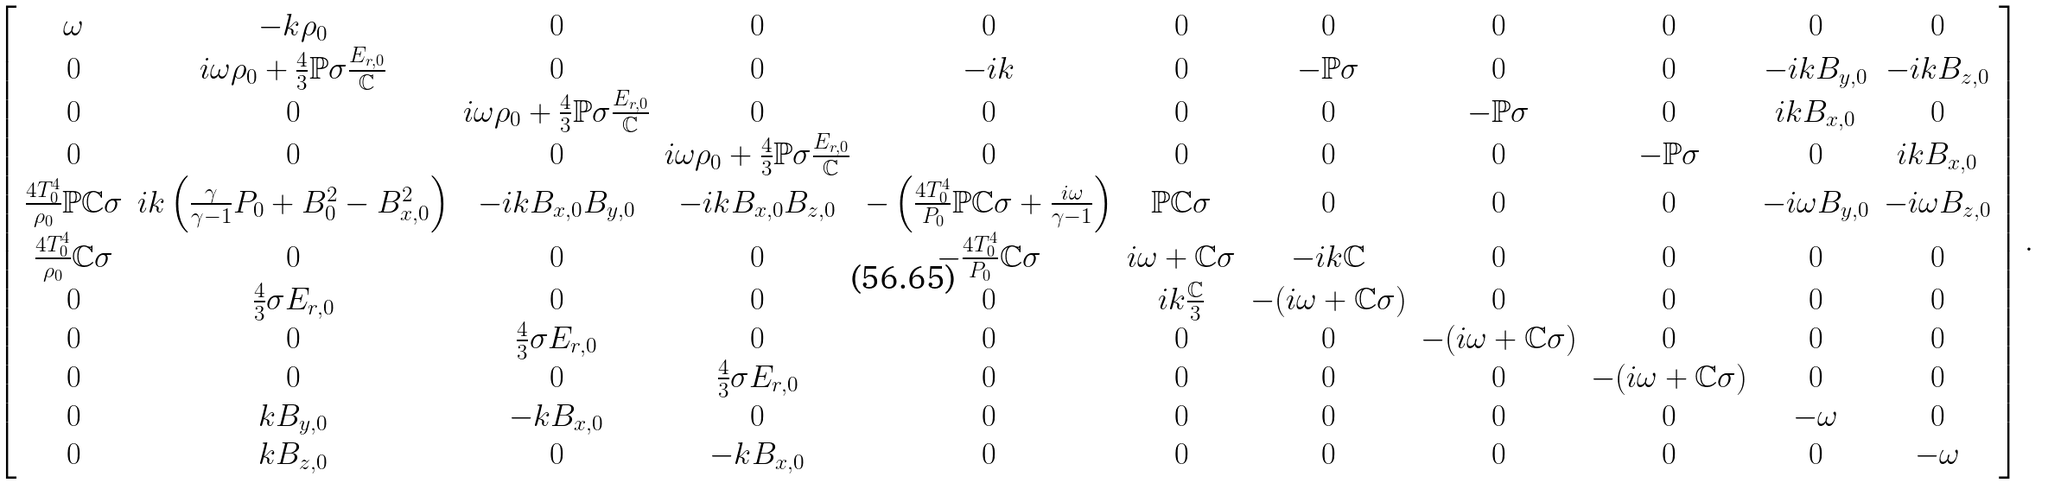<formula> <loc_0><loc_0><loc_500><loc_500>\left [ \begin{array} { c c c c c c c c c c c c } \omega & - k \rho _ { 0 } & 0 & 0 & 0 & 0 & 0 & 0 & 0 & 0 & 0 \\ 0 & i \omega \rho _ { 0 } + \frac { 4 } { 3 } \mathbb { P } \sigma \frac { E _ { r , 0 } } { \mathbb { C } } & 0 & 0 & - i k & 0 & - \mathbb { P } \sigma & 0 & 0 & - i k B _ { y , 0 } & - i k B _ { z , 0 } \\ 0 & 0 & i \omega \rho _ { 0 } + \frac { 4 } { 3 } \mathbb { P } \sigma \frac { E _ { r , 0 } } { \mathbb { C } } & 0 & 0 & 0 & 0 & - \mathbb { P } \sigma & 0 & i k B _ { x , 0 } & 0 \\ 0 & 0 & 0 & i \omega \rho _ { 0 } + \frac { 4 } { 3 } \mathbb { P } \sigma \frac { E _ { r , 0 } } { \mathbb { C } } & 0 & 0 & 0 & 0 & - \mathbb { P } \sigma & 0 & i k B _ { x , 0 } \\ \frac { 4 T _ { 0 } ^ { 4 } } { \rho _ { 0 } } \mathbb { P } \mathbb { C } \sigma & i k \left ( \frac { \gamma } { \gamma - 1 } P _ { 0 } + B _ { 0 } ^ { 2 } - B _ { x , 0 } ^ { 2 } \right ) & - i k B _ { x , 0 } B _ { y , 0 } & - i k B _ { x , 0 } B _ { z , 0 } & - \left ( \frac { 4 T _ { 0 } ^ { 4 } } { P _ { 0 } } \mathbb { P } \mathbb { C } \sigma + \frac { i \omega } { \gamma - 1 } \right ) & \mathbb { P } \mathbb { C } \sigma & 0 & 0 & 0 & - i \omega B _ { y , 0 } & - i \omega B _ { z , 0 } \\ \frac { 4 T _ { 0 } ^ { 4 } } { \rho _ { 0 } } \mathbb { C } \sigma & 0 & 0 & 0 & - \frac { 4 T _ { 0 } ^ { 4 } } { P _ { 0 } } \mathbb { C } \sigma & i \omega + \mathbb { C } \sigma & - i k \mathbb { C } & 0 & 0 & 0 & 0 \\ 0 & \frac { 4 } { 3 } \sigma E _ { r , 0 } & 0 & 0 & 0 & i k \frac { \mathbb { C } } { 3 } & - ( i \omega + \mathbb { C } \sigma ) & 0 & 0 & 0 & 0 \\ 0 & 0 & \frac { 4 } { 3 } \sigma E _ { r , 0 } & 0 & 0 & 0 & 0 & - ( i \omega + \mathbb { C } \sigma ) & 0 & 0 & 0 \\ 0 & 0 & 0 & \frac { 4 } { 3 } \sigma E _ { r , 0 } & 0 & 0 & 0 & 0 & - ( i \omega + \mathbb { C } \sigma ) & 0 & 0 \\ 0 & k B _ { y , 0 } & - k B _ { x , 0 } & 0 & 0 & 0 & 0 & 0 & 0 & - \omega & 0 \\ 0 & k B _ { z , 0 } & 0 & - k B _ { x , 0 } & 0 & 0 & 0 & 0 & 0 & 0 & - \omega \\ \end{array} \right ] .</formula> 